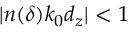Convert formula to latex. <formula><loc_0><loc_0><loc_500><loc_500>| n ( \delta ) k _ { 0 } d _ { z } | < 1</formula> 